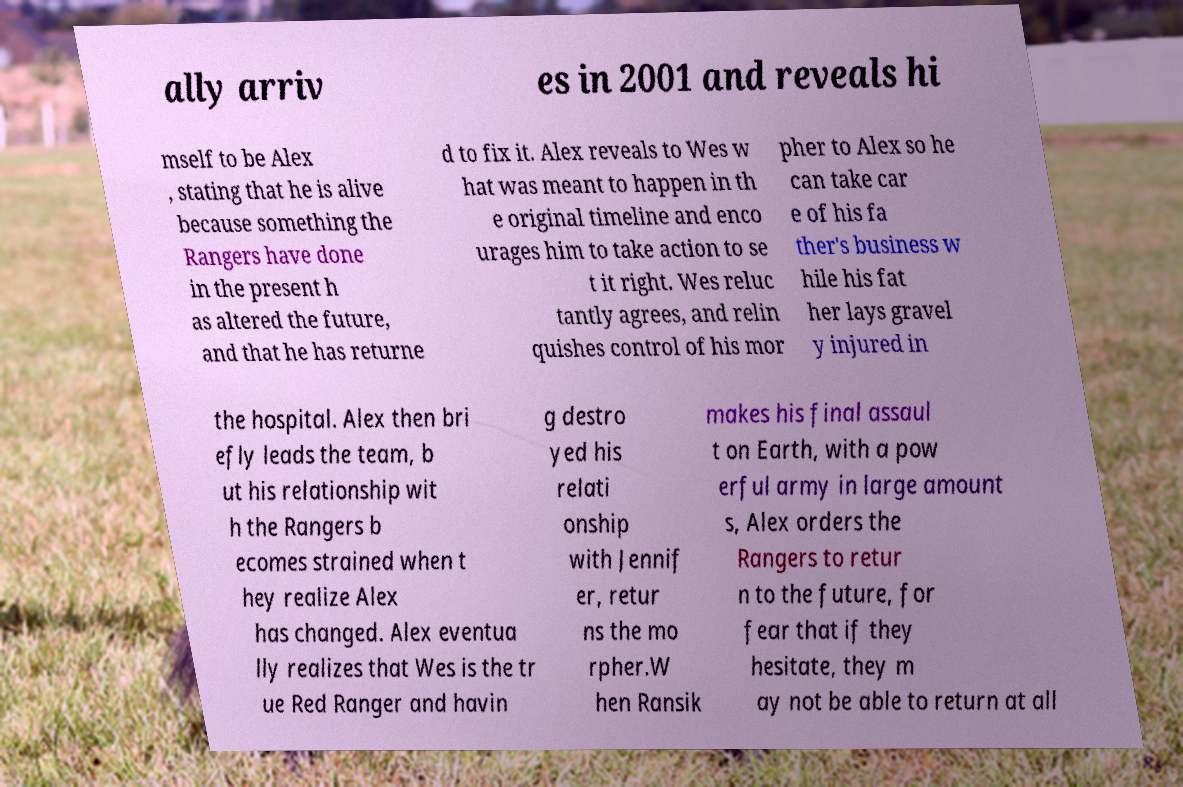Could you extract and type out the text from this image? ally arriv es in 2001 and reveals hi mself to be Alex , stating that he is alive because something the Rangers have done in the present h as altered the future, and that he has returne d to fix it. Alex reveals to Wes w hat was meant to happen in th e original timeline and enco urages him to take action to se t it right. Wes reluc tantly agrees, and relin quishes control of his mor pher to Alex so he can take car e of his fa ther's business w hile his fat her lays gravel y injured in the hospital. Alex then bri efly leads the team, b ut his relationship wit h the Rangers b ecomes strained when t hey realize Alex has changed. Alex eventua lly realizes that Wes is the tr ue Red Ranger and havin g destro yed his relati onship with Jennif er, retur ns the mo rpher.W hen Ransik makes his final assaul t on Earth, with a pow erful army in large amount s, Alex orders the Rangers to retur n to the future, for fear that if they hesitate, they m ay not be able to return at all 